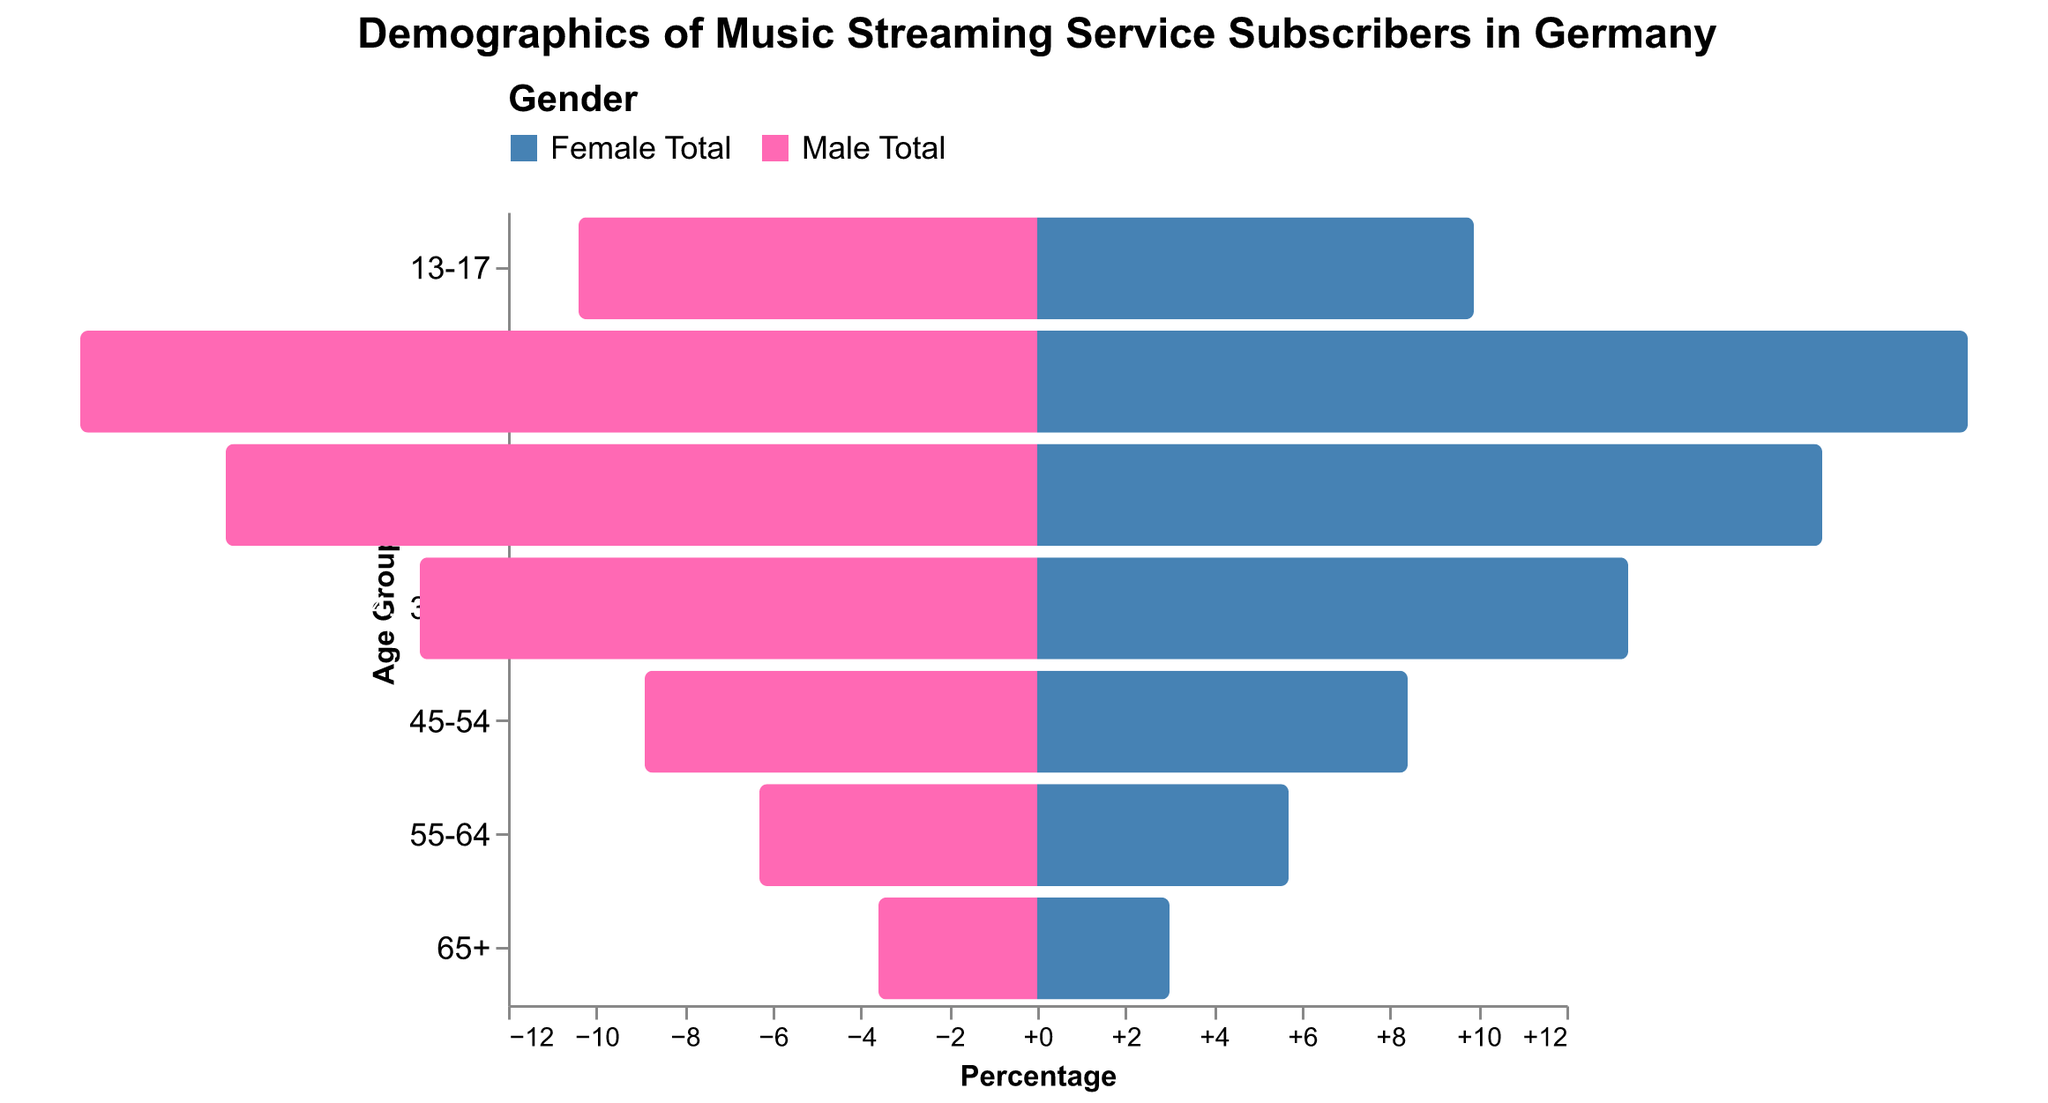What is the title of the figure? The title of the figure is usually displayed prominently at the top or center of the plot to provide viewers an immediate understanding of the content. In this case, based on the provided information, the title is "Demographics of Music Streaming Service Subscribers in Germany."
Answer: Demographics of Music Streaming Service Subscribers in Germany How are males and females represented in the figure? In population pyramids, different colors or patterns are used to distinguish between groups. According to the given data and code, males are represented with one color, and females are represented with another color. Males are shown in blue, and females are shown in pink.
Answer: Males: blue, Females: pink What age group has the highest percentage of Premium Tier subscribers? To find this, we need to look at the Premium Tier Male and Premium Tier Female percentages for each age group and identify the highest total. The age group 18-24 has the highest percentages for both males and females, adding up to (11.5 + 11.2 = 22.7%).
Answer: 18-24 What is the difference in the percentage of Free Tier subscribers between the 18-24 and 13-17 age groups? Calculate the total percentage for the Free Tier in both age groups and then subtract the values: (10.2 + 9.9) - (5.6 + 5.4) = 20.1 - 11 = 9.1. The difference is 9.1%.
Answer: 9.1% Which age group has a higher percentage of male Premium Tier subscribers, 25-34 or 35-44? Look at the percentages of Premium Tier Male for the two age groups and compare. The 25-34 age group has 9.5% and the 35-44 age group has 7.2%. Therefore, the 25-34 age group has a higher percentage.
Answer: 25-34 How does the percentage of Free Tier Male subscribers in the 55-64 age group compare to that in the 45-54 age group? To compare these, look at the Free Tier Male percentages for the specified age groups. For 55-64 it's 3.5%, and for 45-54 it's 4.7%. 4.7% (45-54) is higher than 3.5% (55-64).
Answer: 45-54 What is the sum of the Premium Tier Female subscribers percentages for the age groups 25-34 and 35-44? Add the percentages of each specified age group: 9.2% (25-34) + 6.9% (35-44) = 16.1%.
Answer: 16.1% Which age group has a higher total percentage of subscribers (both Free and Premium Tiers combined), 45-54 or 55-64? Calculate the sum of all tier percentages for each age group and compare: 45-54: (4.7 + 4.5 + 4.2 + 3.9) = 17.3% vs. 55-64: (3.5 + 3.2 + 2.8 + 2.5) = 12.0%. So, the 45-54 age group has a higher total percentage.
Answer: 45-54 Which age group shows a higher percentage of Free Tier subscribers, males aged 35-44 or females aged 25-34? Compare the Free Tier percentages for the specified groups: Males 35-44 have 6.8% and Females 25-34 have 8.6%. So, females aged 25-34 have a higher percentage.
Answer: Females 25-34 What is the total percentage of Premium Tier subscribers in the 65+ age group? Add the percentages of Premium Tier Male and Premium Tier Female for this group: 1.5% + 1.2% = 2.7%.
Answer: 2.7% 